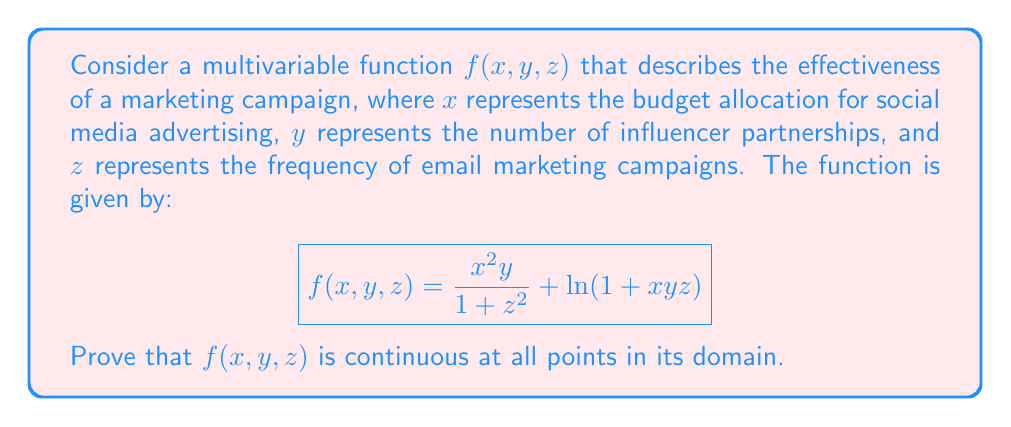Solve this math problem. To prove that $f(x, y, z)$ is continuous at all points in its domain, we need to show that it is composed of continuous functions and that the operations performed on these functions preserve continuity. Let's break this down step-by-step:

1. First, let's identify the domain of $f(x, y, z)$:
   - $x$ and $y$ can be any real number
   - $z$ can be any real number (the denominator $1 + z^2$ is always positive)
   - The argument of the natural logarithm must be positive, so $1 + xyz > 0$

   Therefore, the domain is $\{(x, y, z) \in \mathbb{R}^3 : 1 + xyz > 0\}$

2. Now, let's break down $f(x, y, z)$ into its component functions:
   $$f_1(x, y, z) = \frac{x^2y}{1 + z^2}$$
   $$f_2(x, y, z) = \ln(1 + xyz)$$

3. For $f_1(x, y, z)$:
   - $x^2$, $y$, and $1 + z^2$ are all continuous functions
   - Division of continuous functions is continuous where the denominator is non-zero
   - $1 + z^2$ is always positive, so $f_1$ is continuous everywhere in $\mathbb{R}^3$

4. For $f_2(x, y, z)$:
   - $xyz$ is a continuous function (product of continuous functions)
   - $1 + xyz$ is continuous (sum of continuous functions)
   - $\ln(1 + xyz)$ is continuous where $1 + xyz > 0$, which is precisely our domain

5. The sum of two continuous functions is continuous. Therefore, $f(x, y, z) = f_1(x, y, z) + f_2(x, y, z)$ is continuous on the intersection of their domains, which is $\{(x, y, z) \in \mathbb{R}^3 : 1 + xyz > 0\}$

Thus, we have shown that $f(x, y, z)$ is continuous at all points in its domain.
Answer: $f(x, y, z)$ is continuous for all $(x, y, z) \in \mathbb{R}^3$ such that $1 + xyz > 0$. 